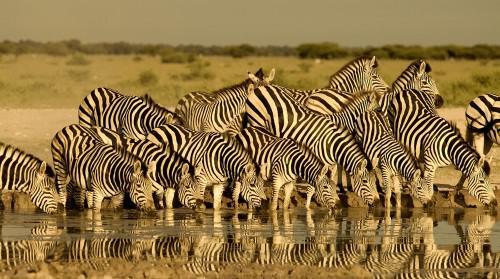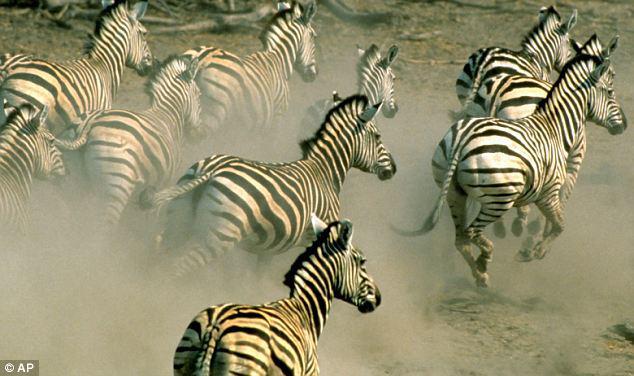The first image is the image on the left, the second image is the image on the right. For the images shown, is this caption "One image shows a row of zebras standing in water with heads lowered to drink." true? Answer yes or no. Yes. The first image is the image on the left, the second image is the image on the right. Given the left and right images, does the statement "The animals in both images are near a body of water." hold true? Answer yes or no. No. 